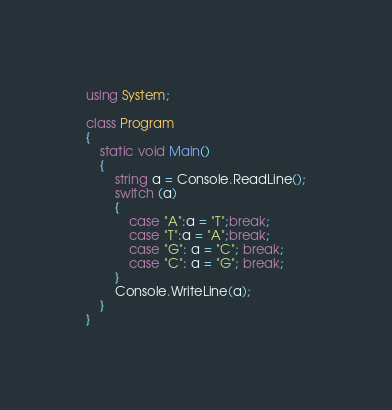<code> <loc_0><loc_0><loc_500><loc_500><_C#_>using System;

class Program
{
    static void Main()
    {
        string a = Console.ReadLine();
        switch (a)
        {
            case "A":a = "T";break;
            case "T":a = "A";break;
            case "G": a = "C"; break;
            case "C": a = "G"; break;
        }
        Console.WriteLine(a);
    }
}
</code> 